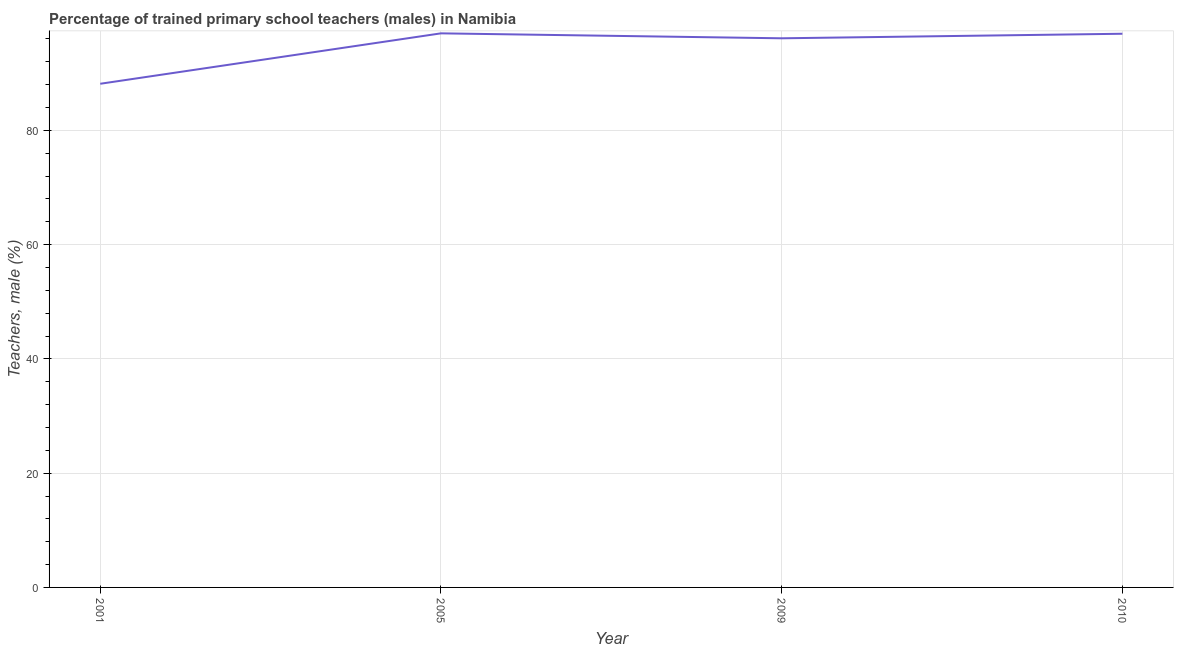What is the percentage of trained male teachers in 2005?
Provide a succinct answer. 96.99. Across all years, what is the maximum percentage of trained male teachers?
Your answer should be compact. 96.99. Across all years, what is the minimum percentage of trained male teachers?
Your answer should be very brief. 88.16. In which year was the percentage of trained male teachers maximum?
Your answer should be very brief. 2005. What is the sum of the percentage of trained male teachers?
Give a very brief answer. 378.19. What is the difference between the percentage of trained male teachers in 2001 and 2009?
Give a very brief answer. -7.96. What is the average percentage of trained male teachers per year?
Make the answer very short. 94.55. What is the median percentage of trained male teachers?
Make the answer very short. 96.52. In how many years, is the percentage of trained male teachers greater than 44 %?
Offer a very short reply. 4. What is the ratio of the percentage of trained male teachers in 2009 to that in 2010?
Make the answer very short. 0.99. What is the difference between the highest and the second highest percentage of trained male teachers?
Provide a succinct answer. 0.07. Is the sum of the percentage of trained male teachers in 2001 and 2005 greater than the maximum percentage of trained male teachers across all years?
Give a very brief answer. Yes. What is the difference between the highest and the lowest percentage of trained male teachers?
Ensure brevity in your answer.  8.83. Does the percentage of trained male teachers monotonically increase over the years?
Ensure brevity in your answer.  No. How many lines are there?
Make the answer very short. 1. Are the values on the major ticks of Y-axis written in scientific E-notation?
Keep it short and to the point. No. Does the graph contain grids?
Keep it short and to the point. Yes. What is the title of the graph?
Offer a terse response. Percentage of trained primary school teachers (males) in Namibia. What is the label or title of the Y-axis?
Give a very brief answer. Teachers, male (%). What is the Teachers, male (%) in 2001?
Provide a succinct answer. 88.16. What is the Teachers, male (%) in 2005?
Make the answer very short. 96.99. What is the Teachers, male (%) in 2009?
Keep it short and to the point. 96.12. What is the Teachers, male (%) of 2010?
Keep it short and to the point. 96.92. What is the difference between the Teachers, male (%) in 2001 and 2005?
Your answer should be compact. -8.83. What is the difference between the Teachers, male (%) in 2001 and 2009?
Your answer should be compact. -7.96. What is the difference between the Teachers, male (%) in 2001 and 2010?
Offer a very short reply. -8.76. What is the difference between the Teachers, male (%) in 2005 and 2009?
Your answer should be very brief. 0.87. What is the difference between the Teachers, male (%) in 2005 and 2010?
Keep it short and to the point. 0.07. What is the difference between the Teachers, male (%) in 2009 and 2010?
Keep it short and to the point. -0.8. What is the ratio of the Teachers, male (%) in 2001 to that in 2005?
Offer a very short reply. 0.91. What is the ratio of the Teachers, male (%) in 2001 to that in 2009?
Give a very brief answer. 0.92. What is the ratio of the Teachers, male (%) in 2001 to that in 2010?
Ensure brevity in your answer.  0.91. What is the ratio of the Teachers, male (%) in 2009 to that in 2010?
Offer a very short reply. 0.99. 